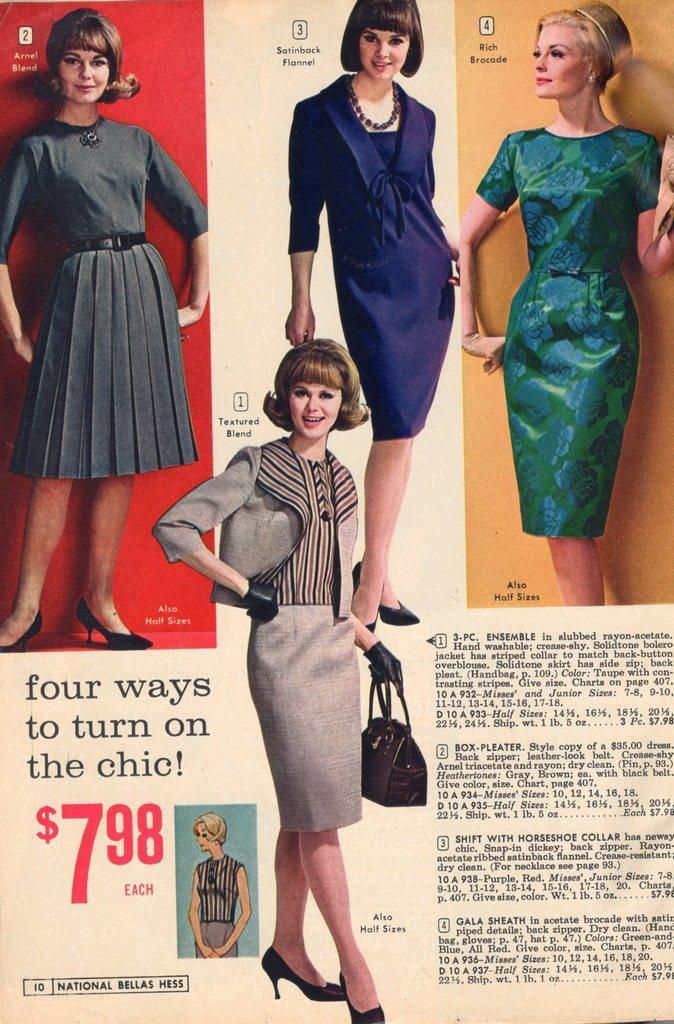How would you summarize this image in a sentence or two? In this picture we can see a newspaper, in the newspaper we can see few women, and a woman is holding a bag. 